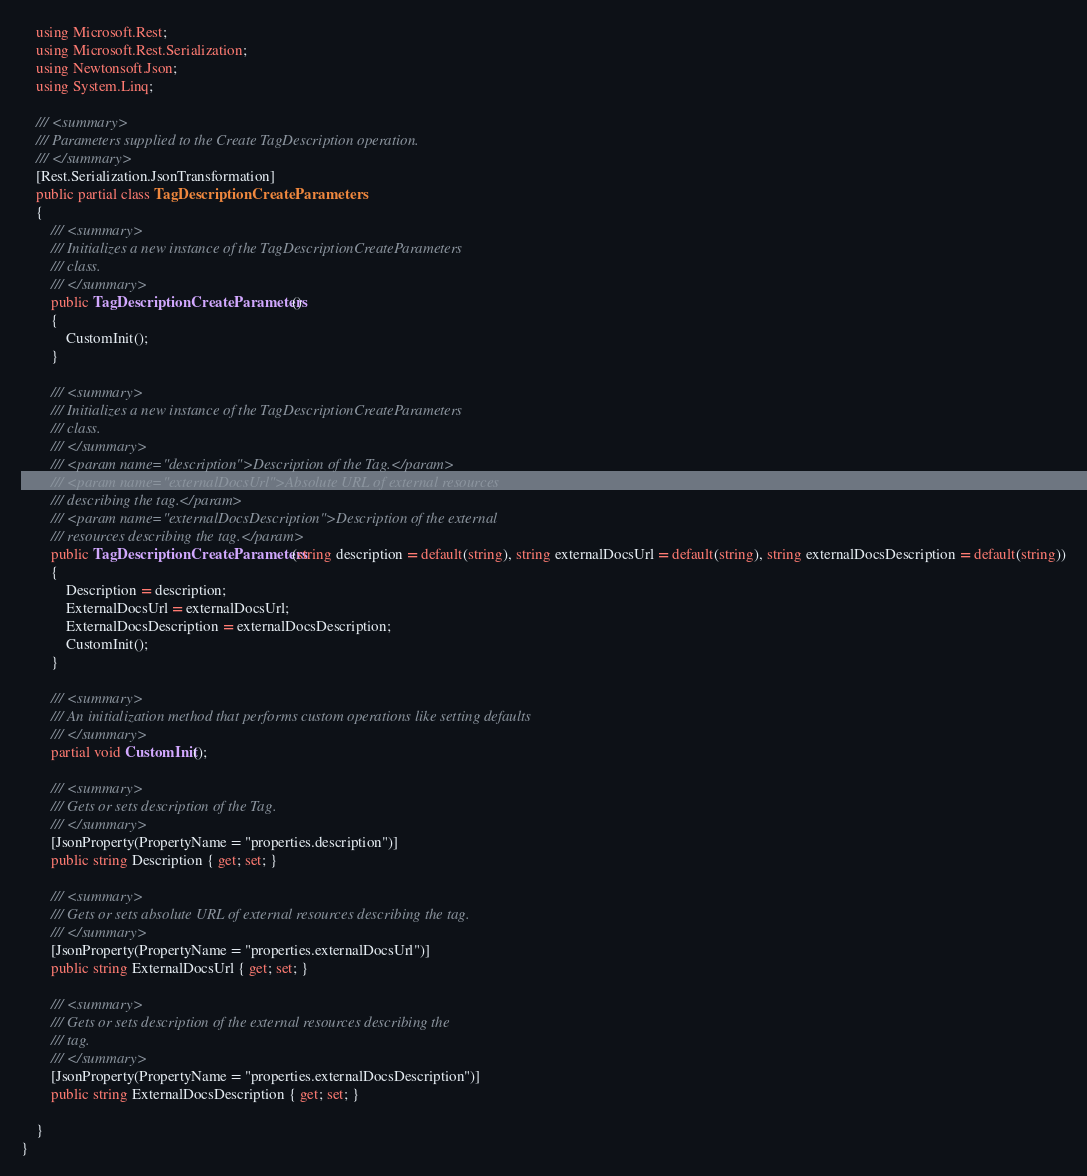<code> <loc_0><loc_0><loc_500><loc_500><_C#_>    using Microsoft.Rest;
    using Microsoft.Rest.Serialization;
    using Newtonsoft.Json;
    using System.Linq;

    /// <summary>
    /// Parameters supplied to the Create TagDescription operation.
    /// </summary>
    [Rest.Serialization.JsonTransformation]
    public partial class TagDescriptionCreateParameters
    {
        /// <summary>
        /// Initializes a new instance of the TagDescriptionCreateParameters
        /// class.
        /// </summary>
        public TagDescriptionCreateParameters()
        {
            CustomInit();
        }

        /// <summary>
        /// Initializes a new instance of the TagDescriptionCreateParameters
        /// class.
        /// </summary>
        /// <param name="description">Description of the Tag.</param>
        /// <param name="externalDocsUrl">Absolute URL of external resources
        /// describing the tag.</param>
        /// <param name="externalDocsDescription">Description of the external
        /// resources describing the tag.</param>
        public TagDescriptionCreateParameters(string description = default(string), string externalDocsUrl = default(string), string externalDocsDescription = default(string))
        {
            Description = description;
            ExternalDocsUrl = externalDocsUrl;
            ExternalDocsDescription = externalDocsDescription;
            CustomInit();
        }

        /// <summary>
        /// An initialization method that performs custom operations like setting defaults
        /// </summary>
        partial void CustomInit();

        /// <summary>
        /// Gets or sets description of the Tag.
        /// </summary>
        [JsonProperty(PropertyName = "properties.description")]
        public string Description { get; set; }

        /// <summary>
        /// Gets or sets absolute URL of external resources describing the tag.
        /// </summary>
        [JsonProperty(PropertyName = "properties.externalDocsUrl")]
        public string ExternalDocsUrl { get; set; }

        /// <summary>
        /// Gets or sets description of the external resources describing the
        /// tag.
        /// </summary>
        [JsonProperty(PropertyName = "properties.externalDocsDescription")]
        public string ExternalDocsDescription { get; set; }

    }
}
</code> 